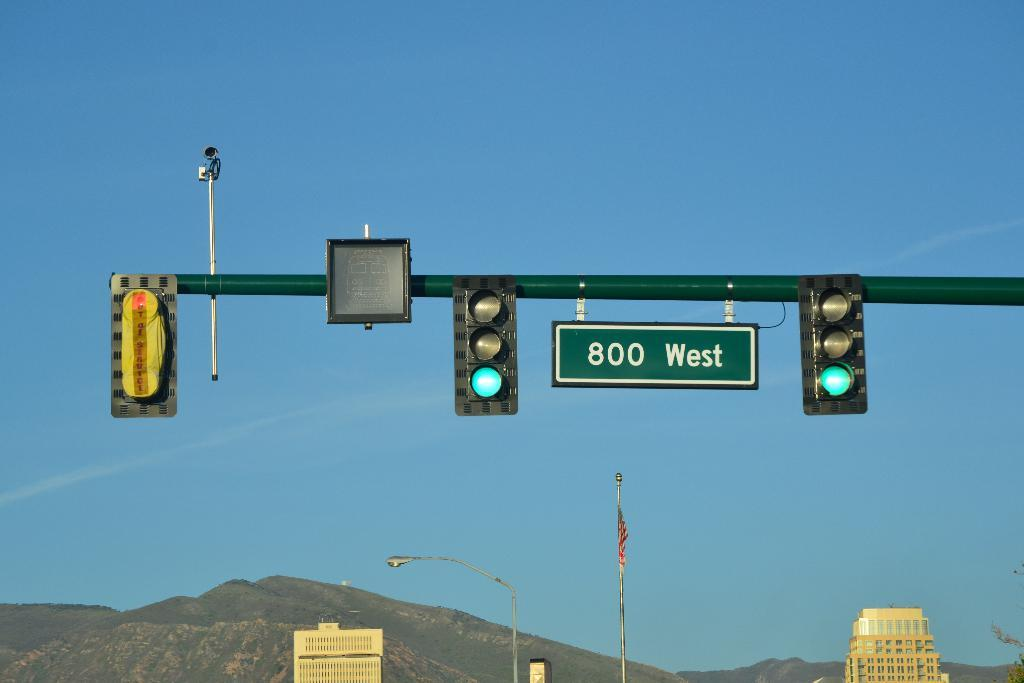Provide a one-sentence caption for the provided image. Traffic lights display a green light with a sign showing they're on 800 West street. 